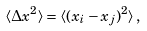<formula> <loc_0><loc_0><loc_500><loc_500>\langle \Delta x ^ { 2 } \rangle = \langle ( x _ { i } - x _ { j } ) ^ { 2 } \rangle \, ,</formula> 